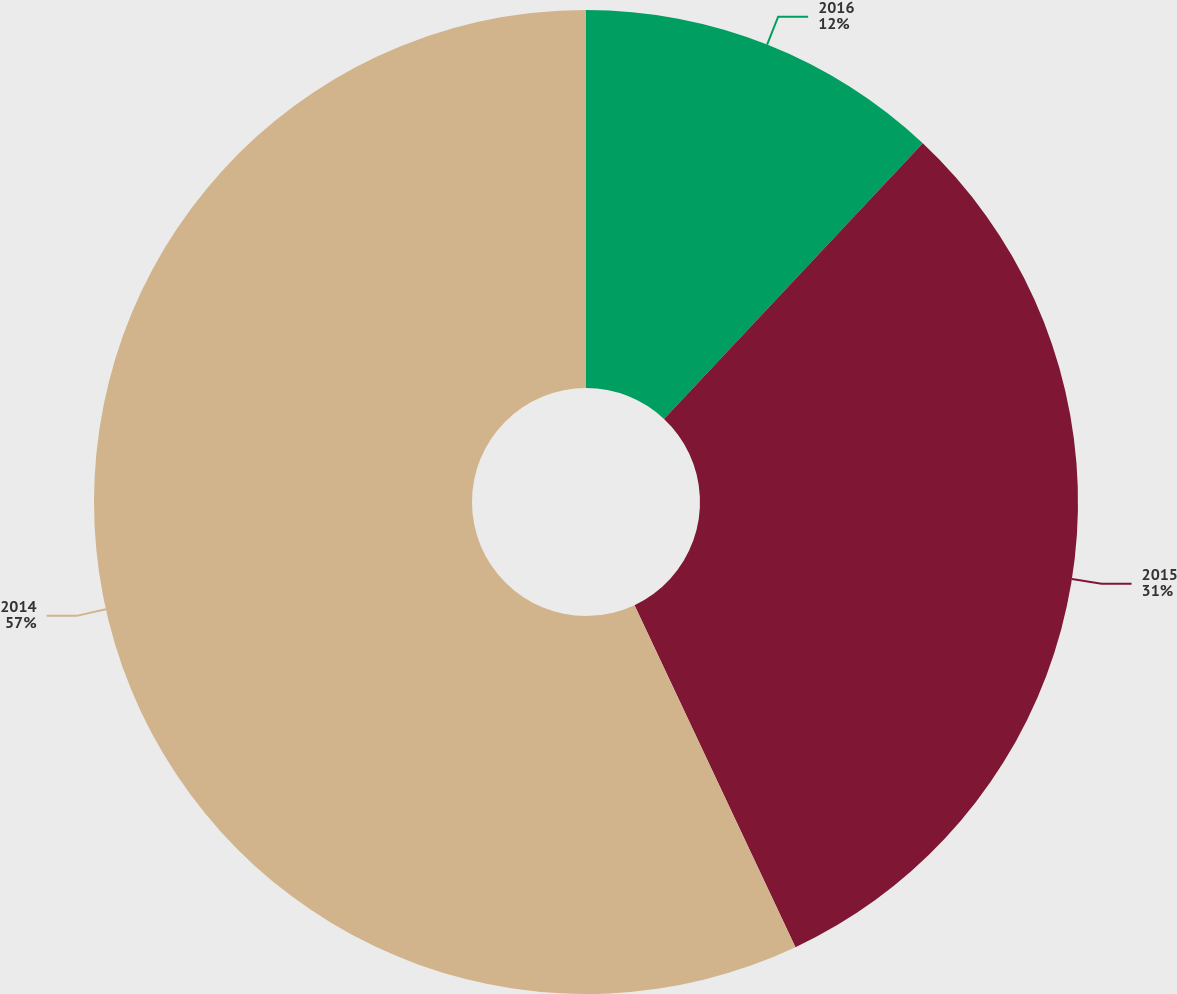Convert chart to OTSL. <chart><loc_0><loc_0><loc_500><loc_500><pie_chart><fcel>2016<fcel>2015<fcel>2014<nl><fcel>12.0%<fcel>31.0%<fcel>57.0%<nl></chart> 